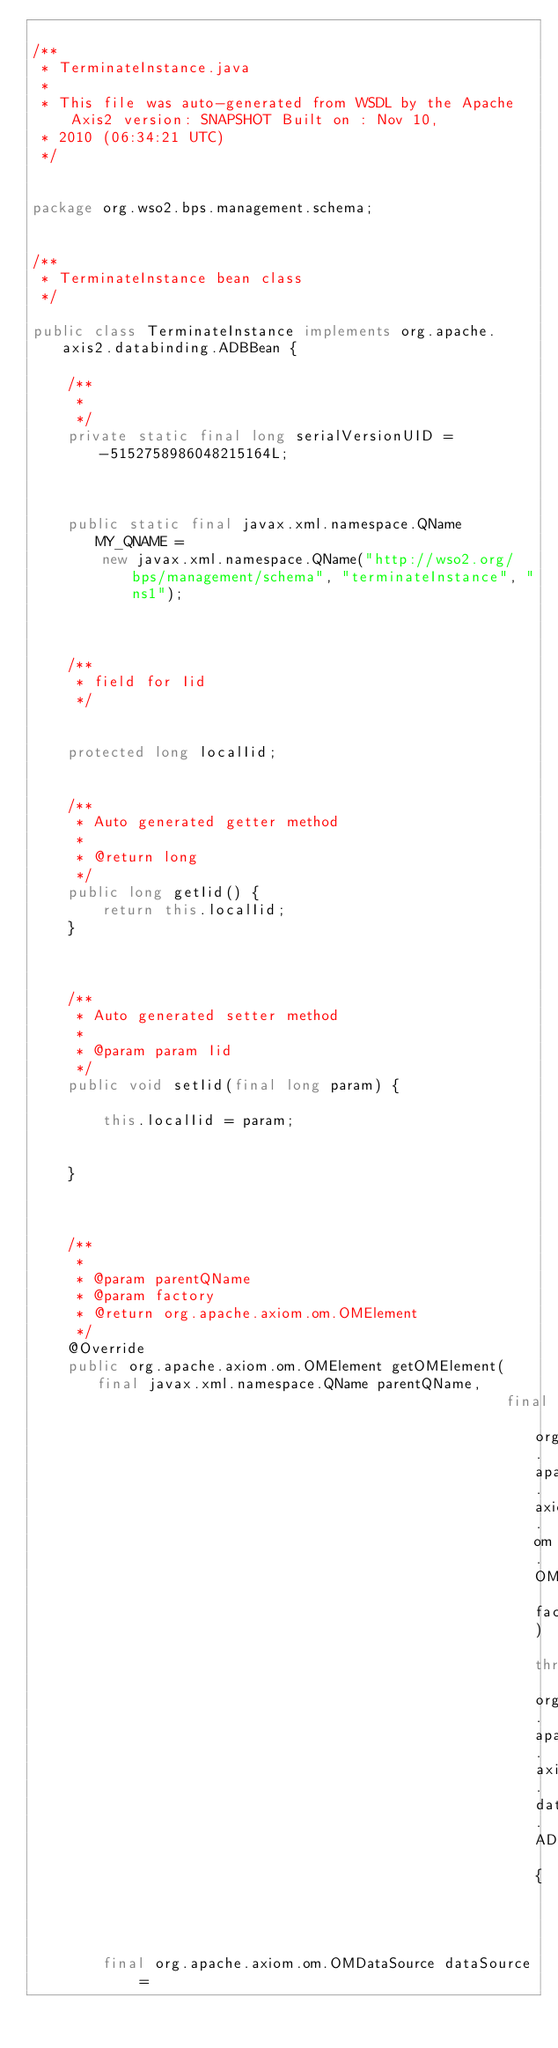Convert code to text. <code><loc_0><loc_0><loc_500><loc_500><_Java_>
/**
 * TerminateInstance.java
 *
 * This file was auto-generated from WSDL by the Apache Axis2 version: SNAPSHOT Built on : Nov 10,
 * 2010 (06:34:21 UTC)
 */


package org.wso2.bps.management.schema;


/**
 * TerminateInstance bean class
 */

public class TerminateInstance implements org.apache.axis2.databinding.ADBBean {

    /**
     *
     */
    private static final long serialVersionUID = -5152758986048215164L;



    public static final javax.xml.namespace.QName MY_QNAME =
        new javax.xml.namespace.QName("http://wso2.org/bps/management/schema", "terminateInstance", "ns1");



    /**
     * field for Iid
     */


    protected long localIid;


    /**
     * Auto generated getter method
     *
     * @return long
     */
    public long getIid() {
        return this.localIid;
    }



    /**
     * Auto generated setter method
     *
     * @param param Iid
     */
    public void setIid(final long param) {

        this.localIid = param;


    }



    /**
     *
     * @param parentQName
     * @param factory
     * @return org.apache.axiom.om.OMElement
     */
    @Override
    public org.apache.axiom.om.OMElement getOMElement(final javax.xml.namespace.QName parentQName,
                                                      final org.apache.axiom.om.OMFactory factory) throws org.apache.axis2.databinding.ADBException {



        final org.apache.axiom.om.OMDataSource dataSource =</code> 